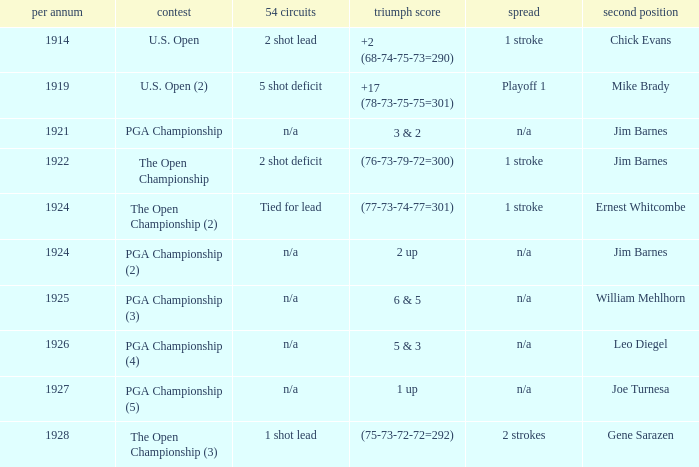WHAT WAS THE WINNING SCORE IN YEAR 1922? (76-73-79-72=300). 